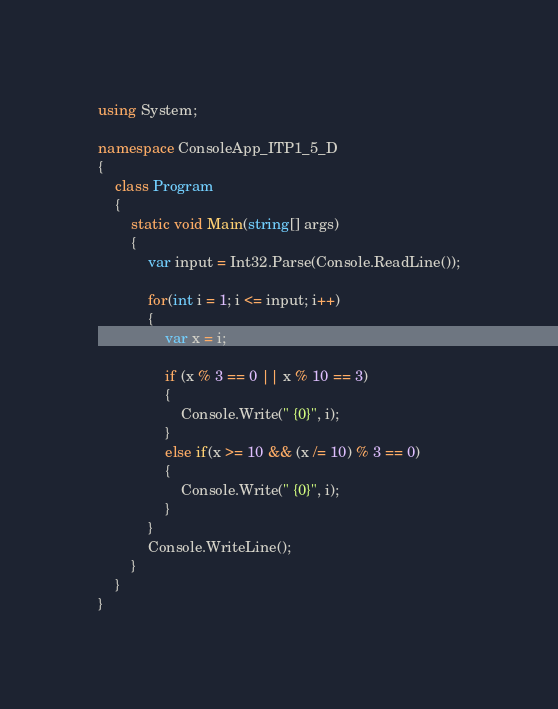Convert code to text. <code><loc_0><loc_0><loc_500><loc_500><_C#_>using System;

namespace ConsoleApp_ITP1_5_D
{
    class Program
    {
        static void Main(string[] args)
        {
            var input = Int32.Parse(Console.ReadLine());

            for(int i = 1; i <= input; i++)
            {
                var x = i;

                if (x % 3 == 0 || x % 10 == 3)
                {
                    Console.Write(" {0}", i);
                }
                else if(x >= 10 && (x /= 10) % 3 == 0)
                {
                    Console.Write(" {0}", i);
                }
            }
            Console.WriteLine();
        }
    }
}

</code> 